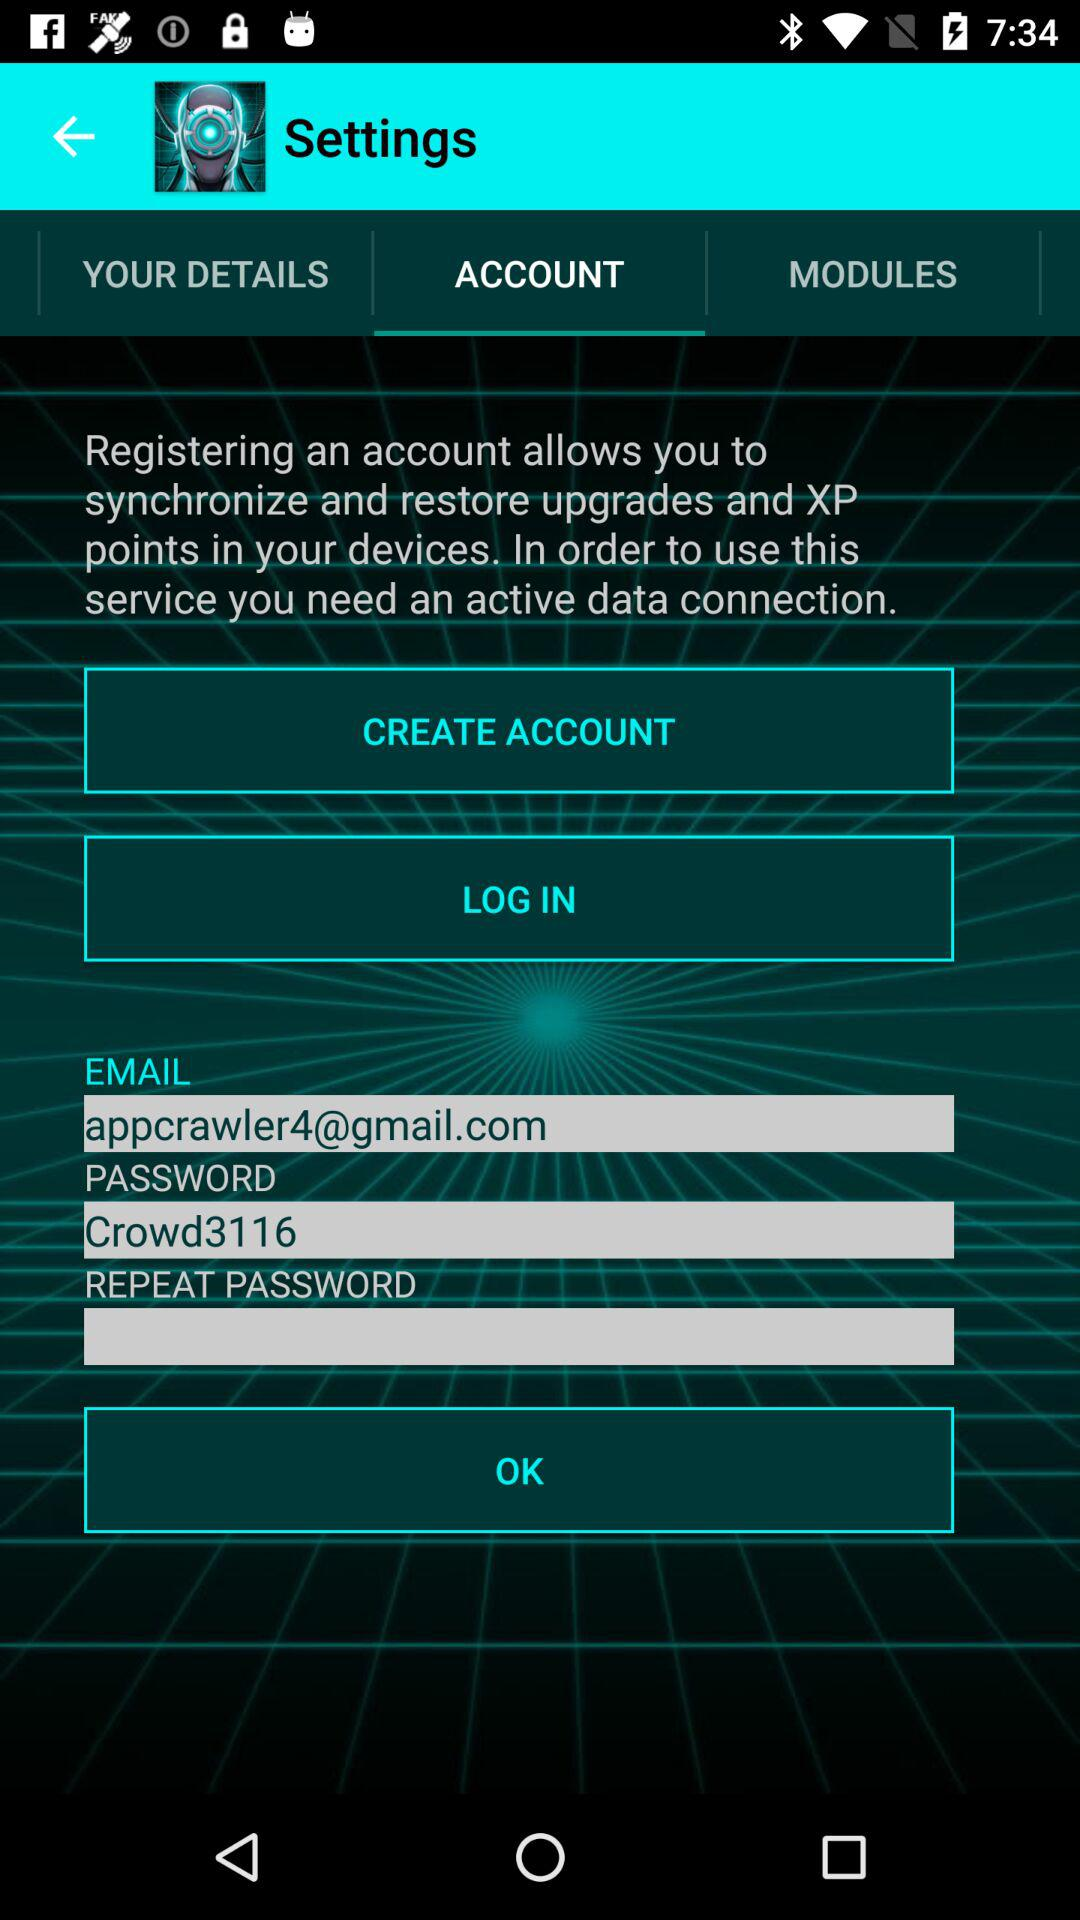Which option is selected in "Settings"? The selected option is "ACCOUNT". 